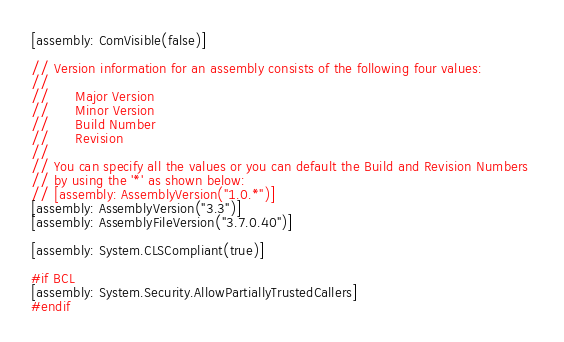<code> <loc_0><loc_0><loc_500><loc_500><_C#_>[assembly: ComVisible(false)]

// Version information for an assembly consists of the following four values:
//
//      Major Version
//      Minor Version 
//      Build Number
//      Revision
//
// You can specify all the values or you can default the Build and Revision Numbers 
// by using the '*' as shown below:
// [assembly: AssemblyVersion("1.0.*")]
[assembly: AssemblyVersion("3.3")]
[assembly: AssemblyFileVersion("3.7.0.40")]

[assembly: System.CLSCompliant(true)]

#if BCL
[assembly: System.Security.AllowPartiallyTrustedCallers]
#endif</code> 